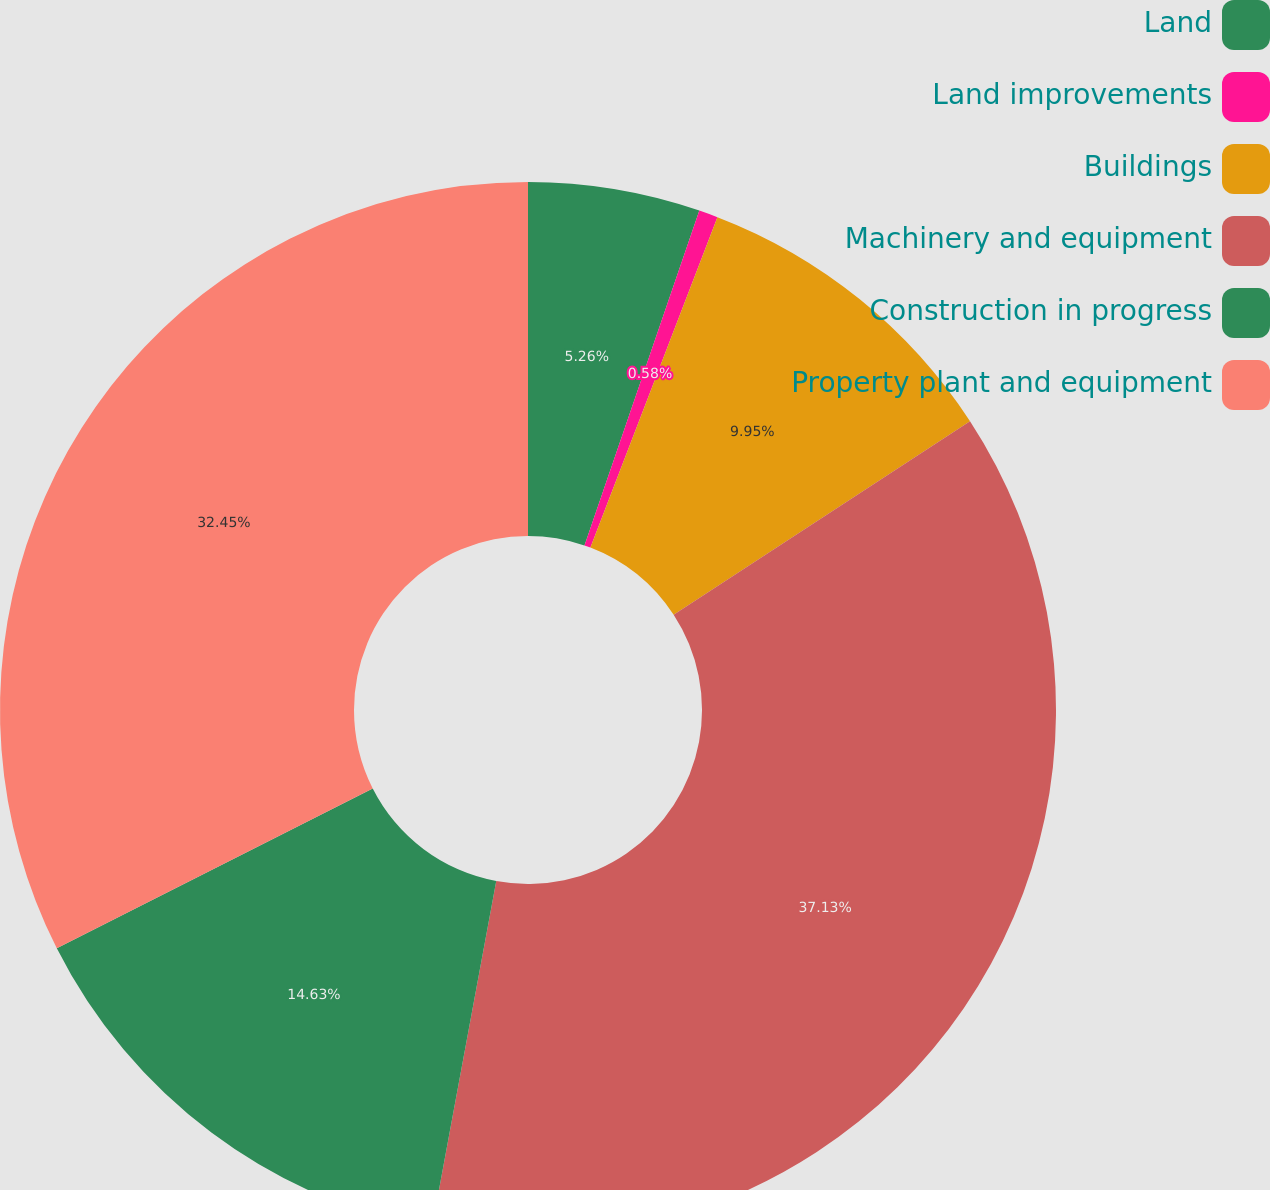Convert chart. <chart><loc_0><loc_0><loc_500><loc_500><pie_chart><fcel>Land<fcel>Land improvements<fcel>Buildings<fcel>Machinery and equipment<fcel>Construction in progress<fcel>Property plant and equipment<nl><fcel>5.26%<fcel>0.58%<fcel>9.95%<fcel>37.13%<fcel>14.63%<fcel>32.45%<nl></chart> 